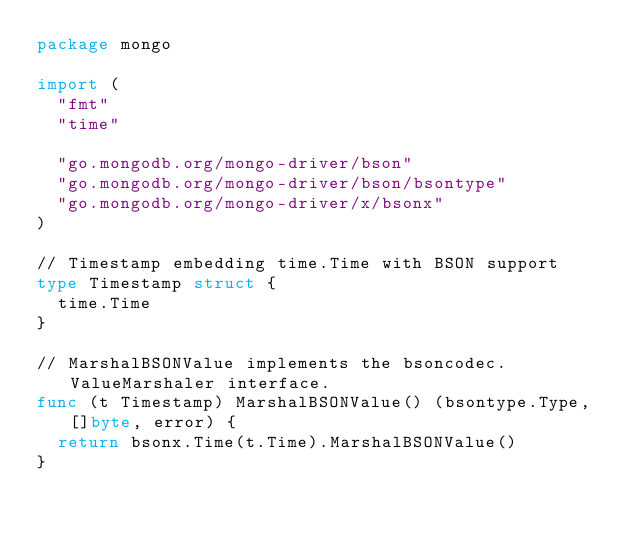<code> <loc_0><loc_0><loc_500><loc_500><_Go_>package mongo

import (
	"fmt"
	"time"

	"go.mongodb.org/mongo-driver/bson"
	"go.mongodb.org/mongo-driver/bson/bsontype"
	"go.mongodb.org/mongo-driver/x/bsonx"
)

// Timestamp embedding time.Time with BSON support
type Timestamp struct {
	time.Time
}

// MarshalBSONValue implements the bsoncodec.ValueMarshaler interface.
func (t Timestamp) MarshalBSONValue() (bsontype.Type, []byte, error) {
	return bsonx.Time(t.Time).MarshalBSONValue()
}
</code> 